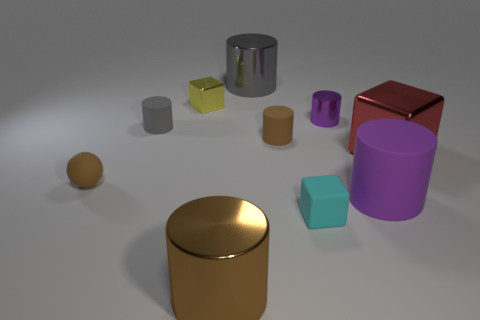Is the number of brown metallic cylinders that are on the left side of the gray rubber thing the same as the number of cyan shiny cylinders?
Your answer should be very brief. Yes. How many matte objects are in front of the red metallic cube and behind the large purple matte thing?
Provide a succinct answer. 1. There is a red metal object that is the same shape as the cyan matte thing; what size is it?
Provide a short and direct response. Large. How many red blocks have the same material as the big brown object?
Give a very brief answer. 1. Are there fewer small spheres that are behind the brown rubber sphere than shiny spheres?
Your answer should be very brief. No. What number of big brown metallic cylinders are there?
Make the answer very short. 1. How many tiny matte cylinders are the same color as the tiny shiny cylinder?
Keep it short and to the point. 0. Is the shape of the large gray shiny thing the same as the purple metallic object?
Offer a terse response. Yes. There is a brown cylinder in front of the small block in front of the tiny shiny cylinder; how big is it?
Provide a short and direct response. Large. Is there a gray object that has the same size as the cyan thing?
Offer a terse response. Yes. 